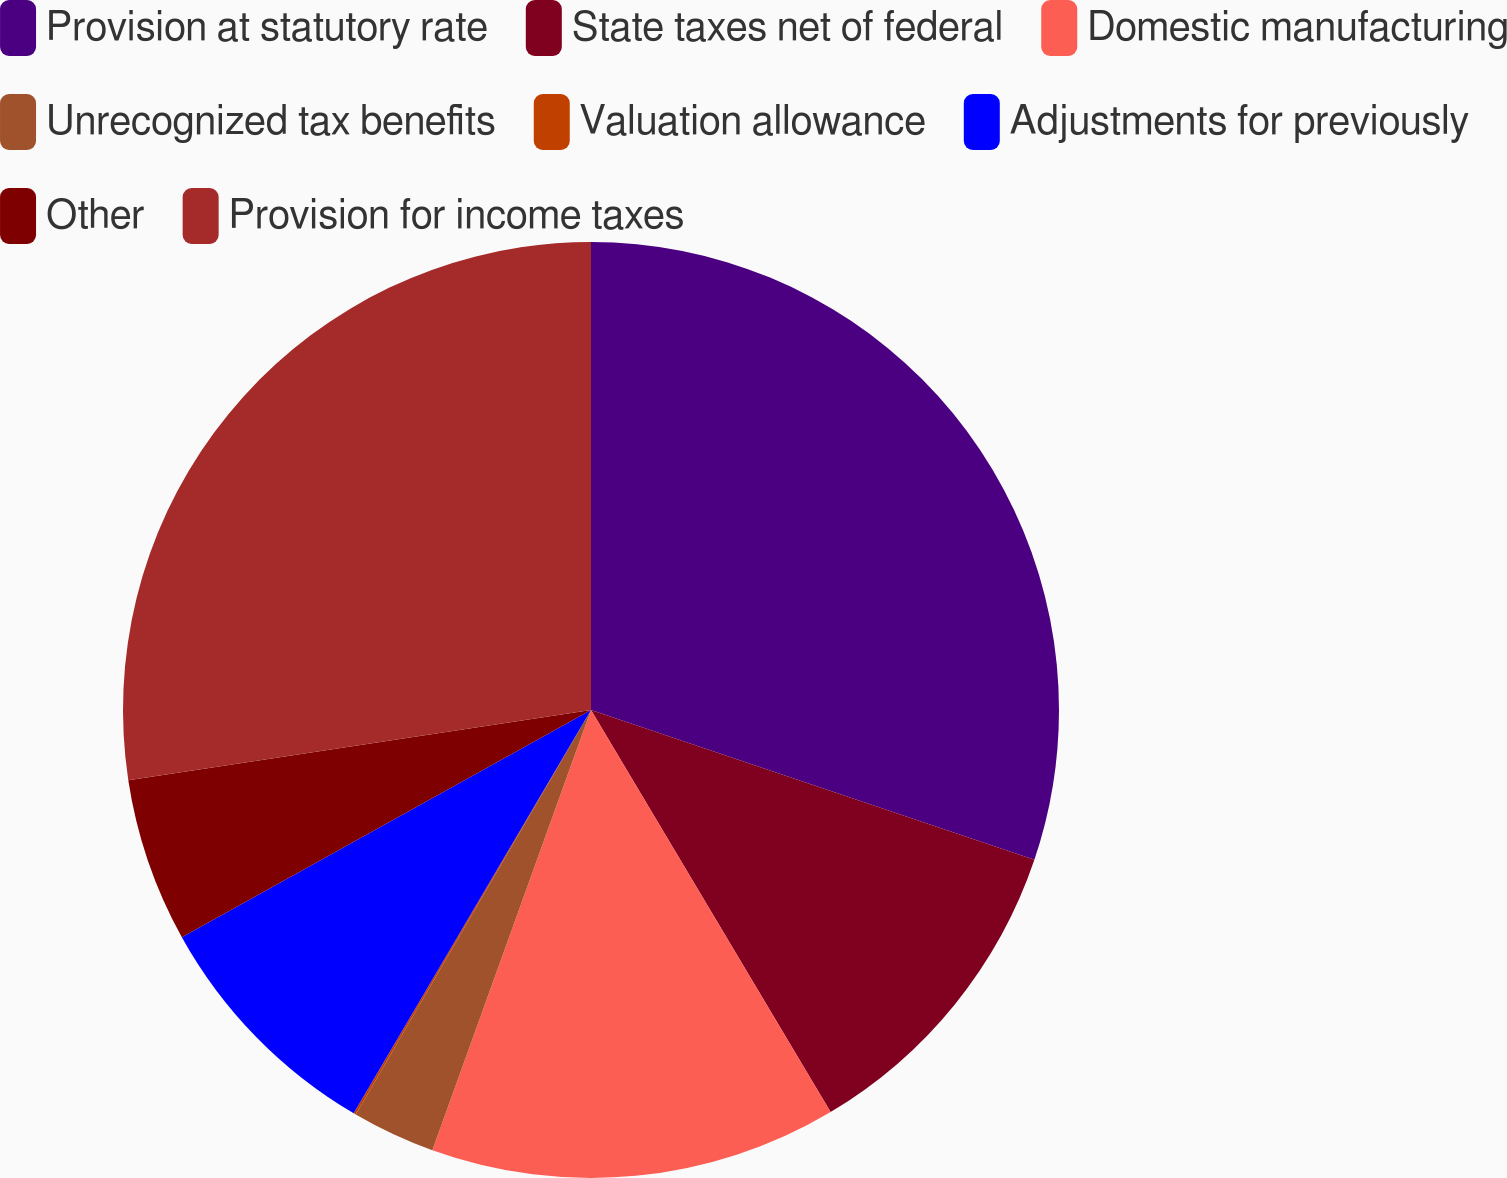Convert chart to OTSL. <chart><loc_0><loc_0><loc_500><loc_500><pie_chart><fcel>Provision at statutory rate<fcel>State taxes net of federal<fcel>Domestic manufacturing<fcel>Unrecognized tax benefits<fcel>Valuation allowance<fcel>Adjustments for previously<fcel>Other<fcel>Provision for income taxes<nl><fcel>30.19%<fcel>11.26%<fcel>14.06%<fcel>2.88%<fcel>0.08%<fcel>8.47%<fcel>5.67%<fcel>27.4%<nl></chart> 